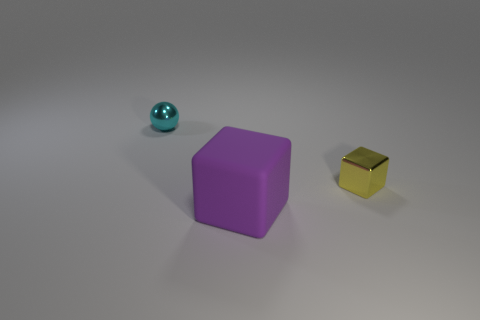Are there any shiny objects of the same color as the small shiny sphere?
Make the answer very short. No. There is a sphere that is the same material as the small yellow block; what size is it?
Ensure brevity in your answer.  Small. There is a metallic object that is to the left of the small metallic object that is in front of the object behind the tiny yellow metallic block; what shape is it?
Ensure brevity in your answer.  Sphere. What size is the other thing that is the same shape as the large object?
Ensure brevity in your answer.  Small. What size is the thing that is on the left side of the small yellow shiny thing and behind the large purple matte object?
Offer a terse response. Small. What color is the big rubber cube?
Provide a short and direct response. Purple. There is a shiny object that is in front of the cyan shiny thing; what size is it?
Keep it short and to the point. Small. There is a cube behind the large rubber thing that is in front of the tiny yellow thing; what number of large rubber blocks are in front of it?
Your response must be concise. 1. What is the color of the tiny thing that is right of the metallic thing that is on the left side of the yellow shiny thing?
Your response must be concise. Yellow. Are there any yellow matte cylinders that have the same size as the matte cube?
Provide a short and direct response. No. 